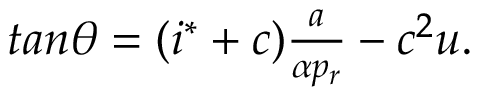<formula> <loc_0><loc_0><loc_500><loc_500>\begin{array} { r } { t a n \theta = ( i ^ { * } + c ) \frac { a } { \alpha p _ { r } } - c ^ { 2 } u . } \end{array}</formula> 